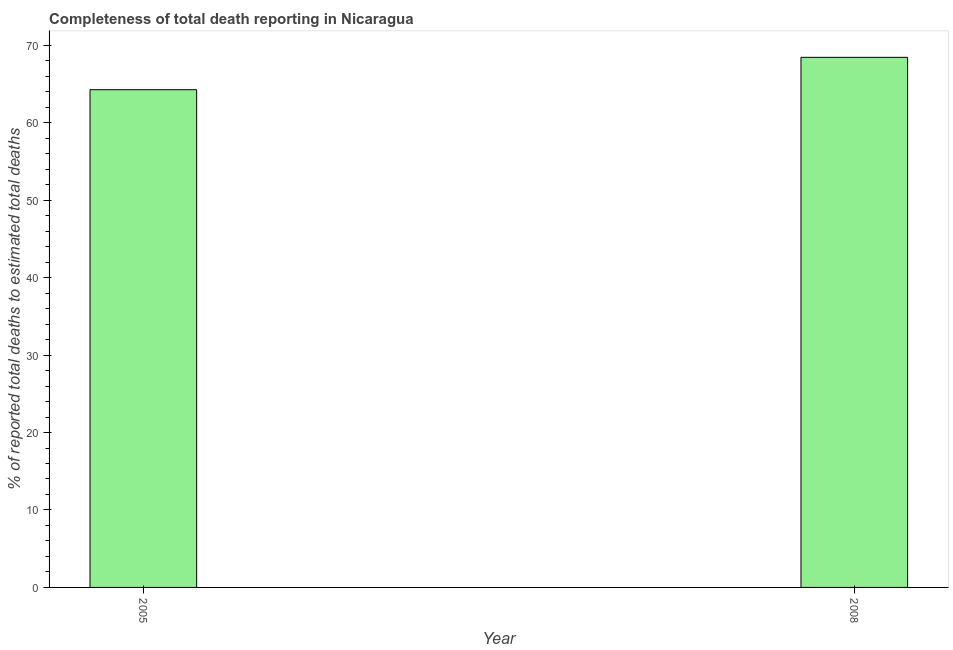Does the graph contain grids?
Keep it short and to the point. No. What is the title of the graph?
Offer a terse response. Completeness of total death reporting in Nicaragua. What is the label or title of the X-axis?
Ensure brevity in your answer.  Year. What is the label or title of the Y-axis?
Make the answer very short. % of reported total deaths to estimated total deaths. What is the completeness of total death reports in 2008?
Give a very brief answer. 68.44. Across all years, what is the maximum completeness of total death reports?
Give a very brief answer. 68.44. Across all years, what is the minimum completeness of total death reports?
Keep it short and to the point. 64.26. In which year was the completeness of total death reports maximum?
Your response must be concise. 2008. What is the sum of the completeness of total death reports?
Give a very brief answer. 132.69. What is the difference between the completeness of total death reports in 2005 and 2008?
Your response must be concise. -4.18. What is the average completeness of total death reports per year?
Give a very brief answer. 66.35. What is the median completeness of total death reports?
Offer a very short reply. 66.35. Do a majority of the years between 2008 and 2005 (inclusive) have completeness of total death reports greater than 50 %?
Your answer should be very brief. No. What is the ratio of the completeness of total death reports in 2005 to that in 2008?
Keep it short and to the point. 0.94. In how many years, is the completeness of total death reports greater than the average completeness of total death reports taken over all years?
Keep it short and to the point. 1. How many bars are there?
Provide a succinct answer. 2. How many years are there in the graph?
Your response must be concise. 2. What is the difference between two consecutive major ticks on the Y-axis?
Give a very brief answer. 10. Are the values on the major ticks of Y-axis written in scientific E-notation?
Offer a very short reply. No. What is the % of reported total deaths to estimated total deaths of 2005?
Your answer should be very brief. 64.26. What is the % of reported total deaths to estimated total deaths in 2008?
Ensure brevity in your answer.  68.44. What is the difference between the % of reported total deaths to estimated total deaths in 2005 and 2008?
Your answer should be compact. -4.18. What is the ratio of the % of reported total deaths to estimated total deaths in 2005 to that in 2008?
Offer a very short reply. 0.94. 